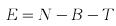<formula> <loc_0><loc_0><loc_500><loc_500>E = N - B - T</formula> 